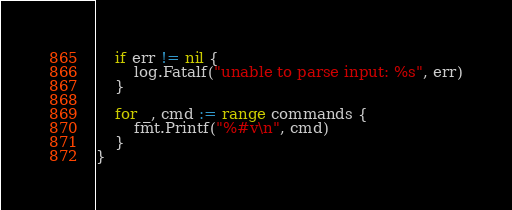<code> <loc_0><loc_0><loc_500><loc_500><_Go_>	if err != nil {
		log.Fatalf("unable to parse input: %s", err)
	}

	for _, cmd := range commands {
		fmt.Printf("%#v\n", cmd)
	}
}
</code> 